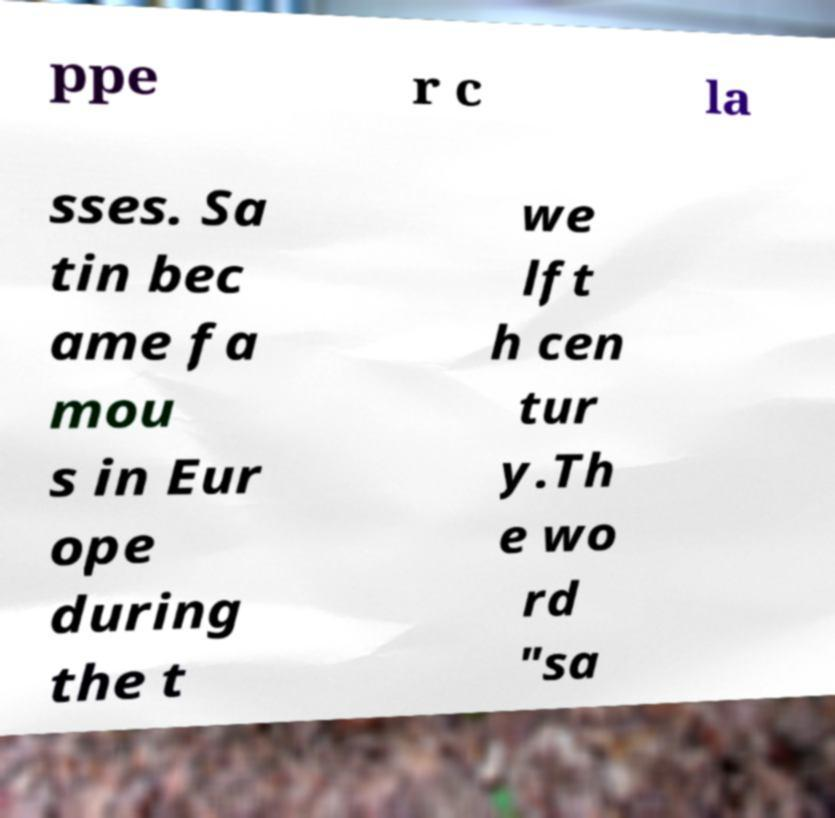There's text embedded in this image that I need extracted. Can you transcribe it verbatim? ppe r c la sses. Sa tin bec ame fa mou s in Eur ope during the t we lft h cen tur y.Th e wo rd "sa 